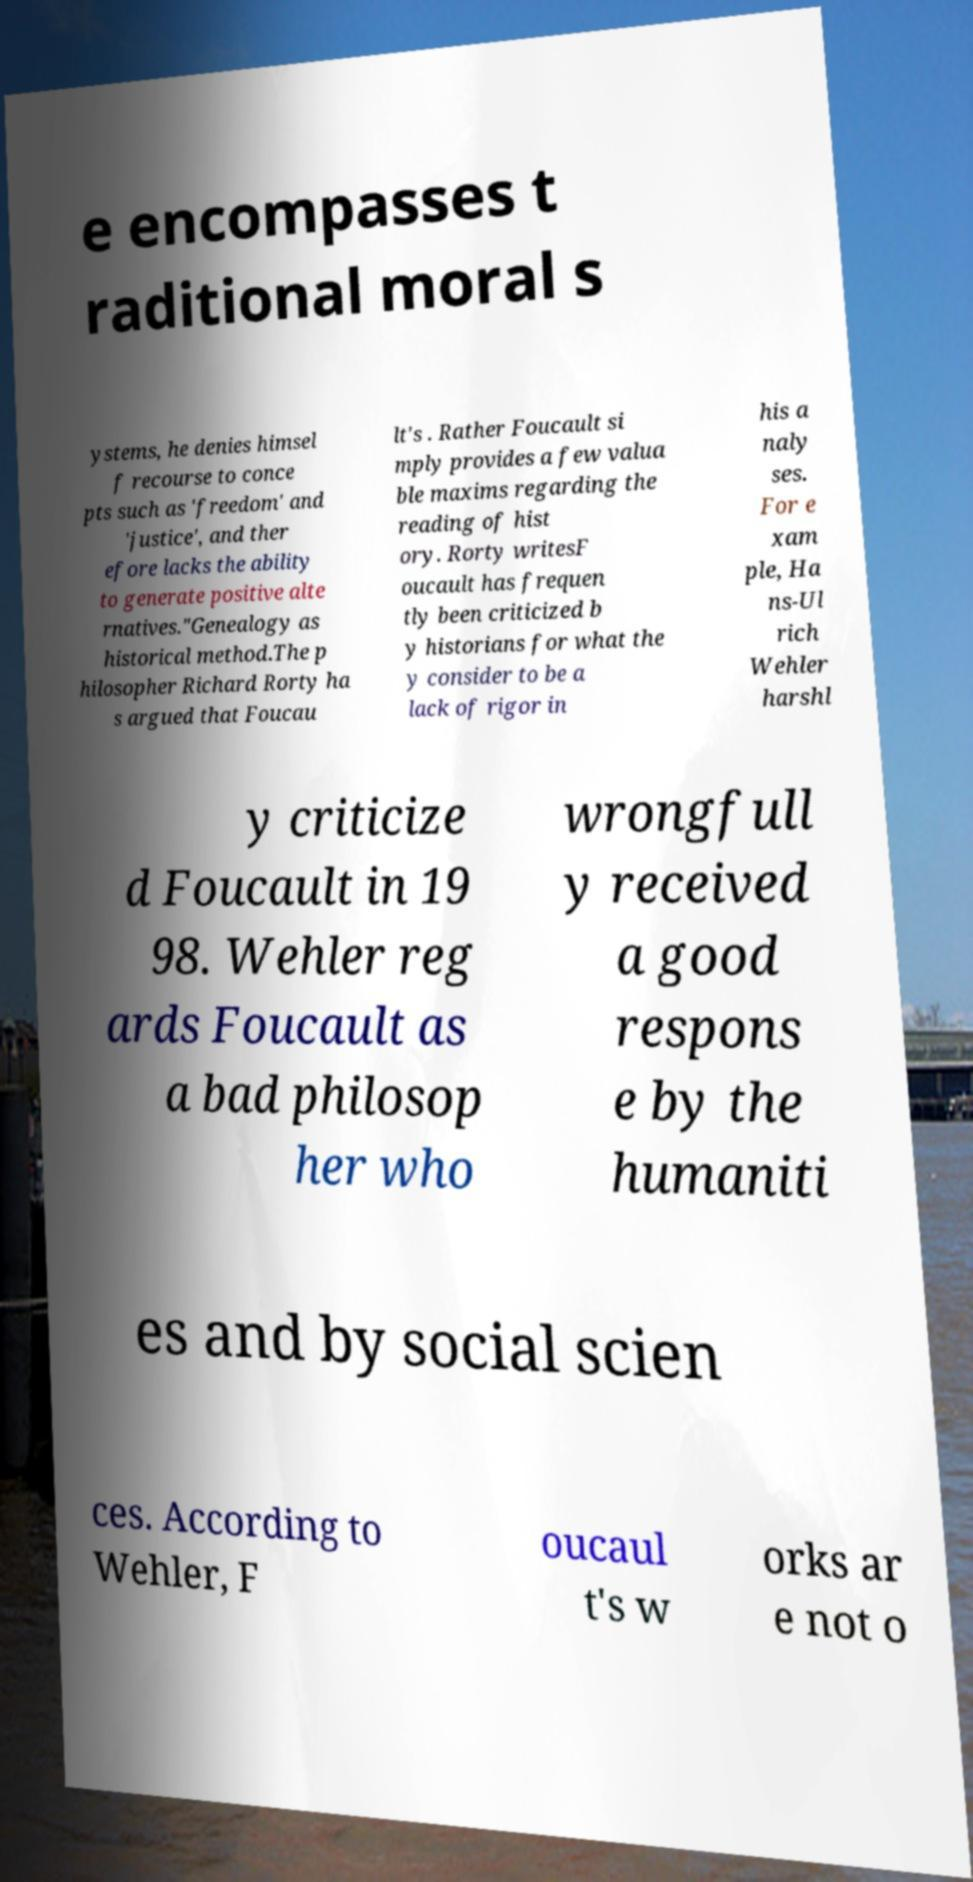Could you assist in decoding the text presented in this image and type it out clearly? e encompasses t raditional moral s ystems, he denies himsel f recourse to conce pts such as 'freedom' and 'justice', and ther efore lacks the ability to generate positive alte rnatives."Genealogy as historical method.The p hilosopher Richard Rorty ha s argued that Foucau lt's . Rather Foucault si mply provides a few valua ble maxims regarding the reading of hist ory. Rorty writesF oucault has frequen tly been criticized b y historians for what the y consider to be a lack of rigor in his a naly ses. For e xam ple, Ha ns-Ul rich Wehler harshl y criticize d Foucault in 19 98. Wehler reg ards Foucault as a bad philosop her who wrongfull y received a good respons e by the humaniti es and by social scien ces. According to Wehler, F oucaul t's w orks ar e not o 